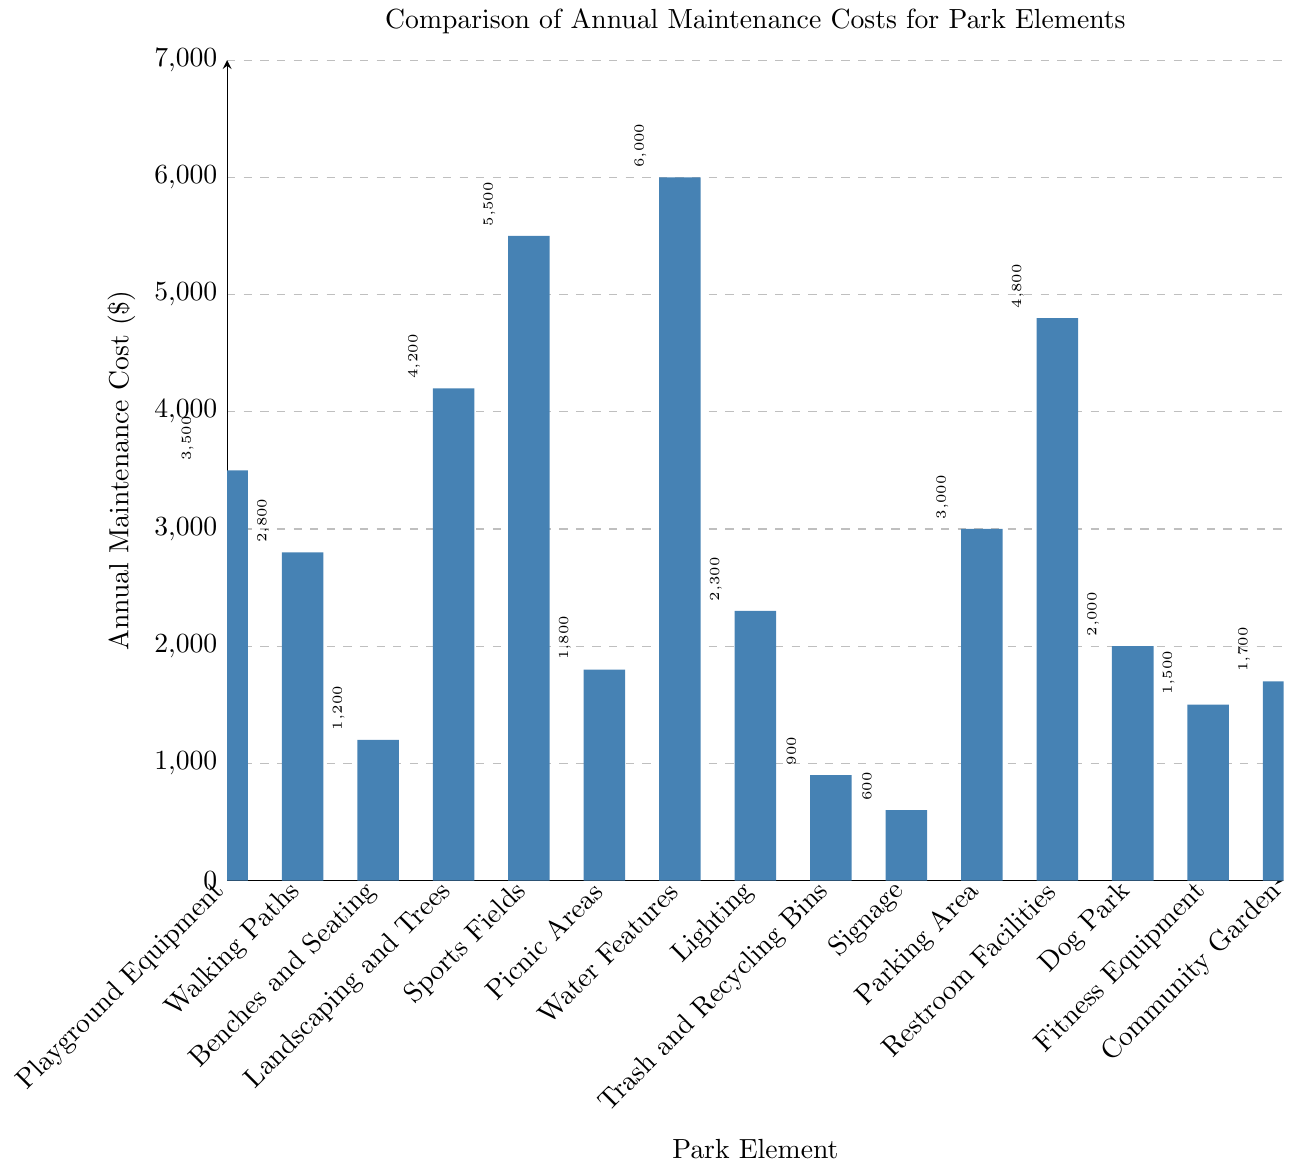Which park element has the highest annual maintenance cost? The tallest bar on the chart represents the element with the highest cost. The bar for Water Features is the tallest, indicating it has the highest maintenance cost.
Answer: Water Features What is the difference in annual maintenance costs between Sports Fields and Lighting? Look at the heights representing Sports Fields ($5500) and Lighting ($2300). Subtract Lighting's cost from Sports Fields' cost: $5500 - $2300.
Answer: $3200 Which park elements cost less than $1000 annually for maintenance? Identify bars with a height less than $1000. The bars for Trash and Recycling Bins and Signage meet this criterion.
Answer: Trash and Recycling Bins, Signage What is the total annual maintenance cost for Playground Equipment, Walking Paths, and Benches and Seating? Sum the values of these elements: Playground Equipment ($3500), Walking Paths ($2800), and Benches and Seating ($1200). The total is $3500 + $2800 + $1200.
Answer: $7500 How does the cost of maintaining Restroom Facilities compare to maintaining the Dog Park? Compare the heights of Restroom Facilities ($4800) and Dog Park ($2000). Restroom Facilities cost more.
Answer: Restroom Facilities cost more What is the average annual maintenance cost across all park elements? Sum the maintenance costs for all elements and divide by the number of elements (15). Total cost is $42000, so the average is $42000 / 15.
Answer: $2800 Which three park elements have the highest annual maintenance costs? Identify the three tallest bars. They represent Water Features ($6000), Sports Fields ($5500), and Restroom Facilities ($4800).
Answer: Water Features, Sports Fields, Restroom Facilities What is the maintenance cost range for the park elements? Determine the difference between the highest and lowest costs. The highest bar is Water Features ($6000) and the lowest is Signage ($600). The range is $6000 - $600.
Answer: $5400 What is the combined annual maintenance cost for Landscaping and Trees, Sports Fields, and Parking Area? Add the values: Landscaping and Trees ($4200), Sports Fields ($5500), and Parking Area ($3000). The total is $4200 + $5500 + $3000.
Answer: $12700 Is the annual cost of maintaining the Community Garden greater or smaller than maintaining Fitness Equipment? Compare the heights. Community Garden ($1700) is greater than Fitness Equipment ($1500).
Answer: Greater 